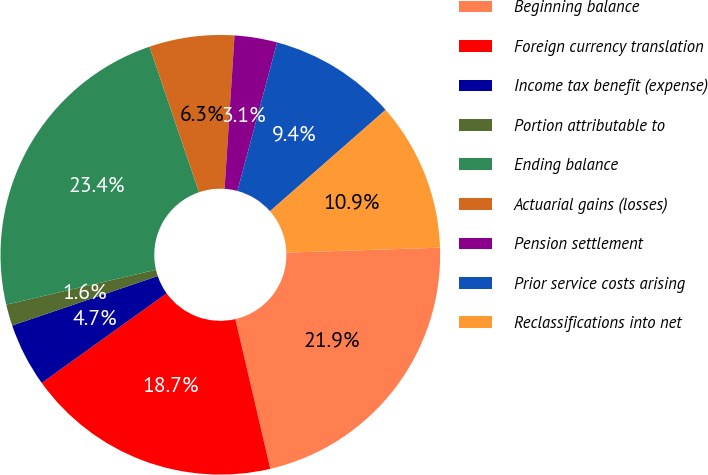<chart> <loc_0><loc_0><loc_500><loc_500><pie_chart><fcel>Beginning balance<fcel>Foreign currency translation<fcel>Income tax benefit (expense)<fcel>Portion attributable to<fcel>Ending balance<fcel>Actuarial gains (losses)<fcel>Pension settlement<fcel>Prior service costs arising<fcel>Reclassifications into net<nl><fcel>21.86%<fcel>18.74%<fcel>4.69%<fcel>1.57%<fcel>23.42%<fcel>6.25%<fcel>3.13%<fcel>9.38%<fcel>10.94%<nl></chart> 